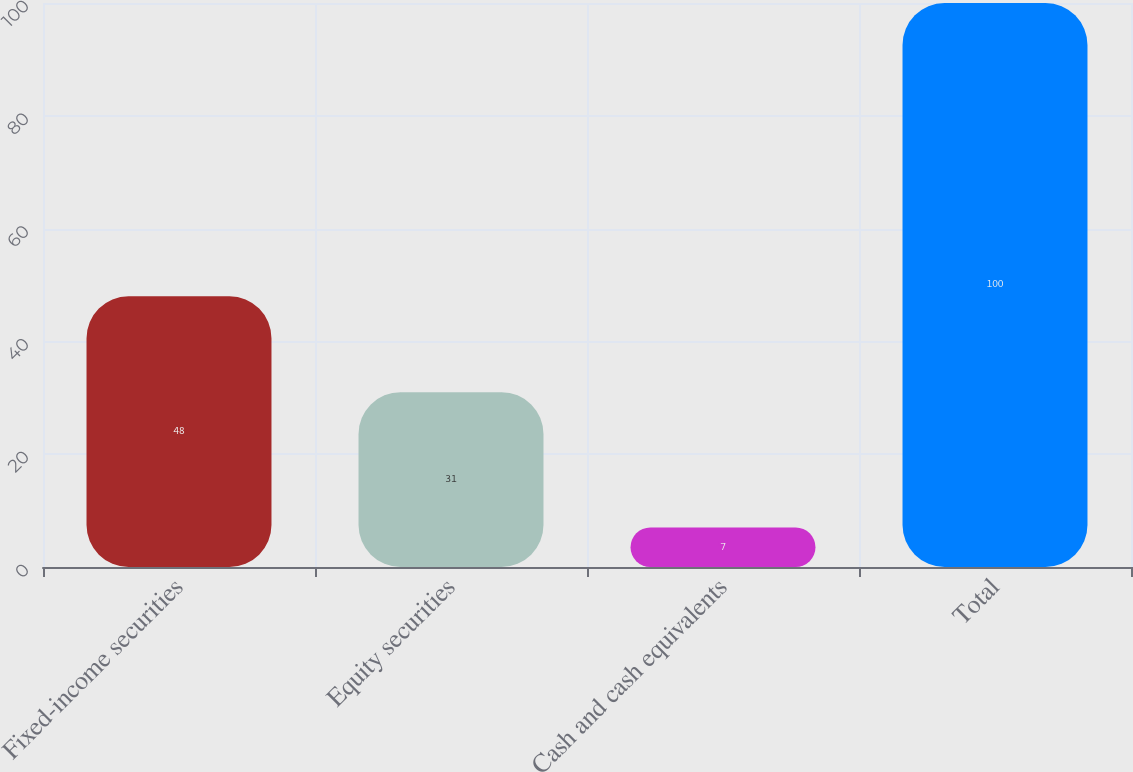<chart> <loc_0><loc_0><loc_500><loc_500><bar_chart><fcel>Fixed-income securities<fcel>Equity securities<fcel>Cash and cash equivalents<fcel>Total<nl><fcel>48<fcel>31<fcel>7<fcel>100<nl></chart> 